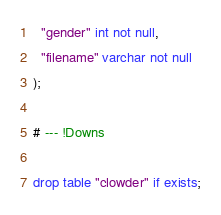<code> <loc_0><loc_0><loc_500><loc_500><_SQL_>  "gender" int not null,
  "filename" varchar not null
);

# --- !Downs

drop table "clowder" if exists;
</code> 